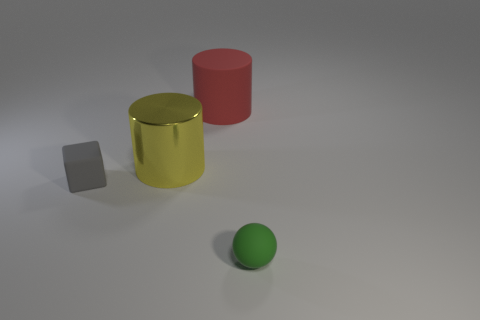Add 3 tiny yellow matte cylinders. How many objects exist? 7 Subtract all balls. How many objects are left? 3 Subtract all small green spheres. Subtract all large cylinders. How many objects are left? 1 Add 2 large metal objects. How many large metal objects are left? 3 Add 2 red rubber objects. How many red rubber objects exist? 3 Subtract 0 green cubes. How many objects are left? 4 